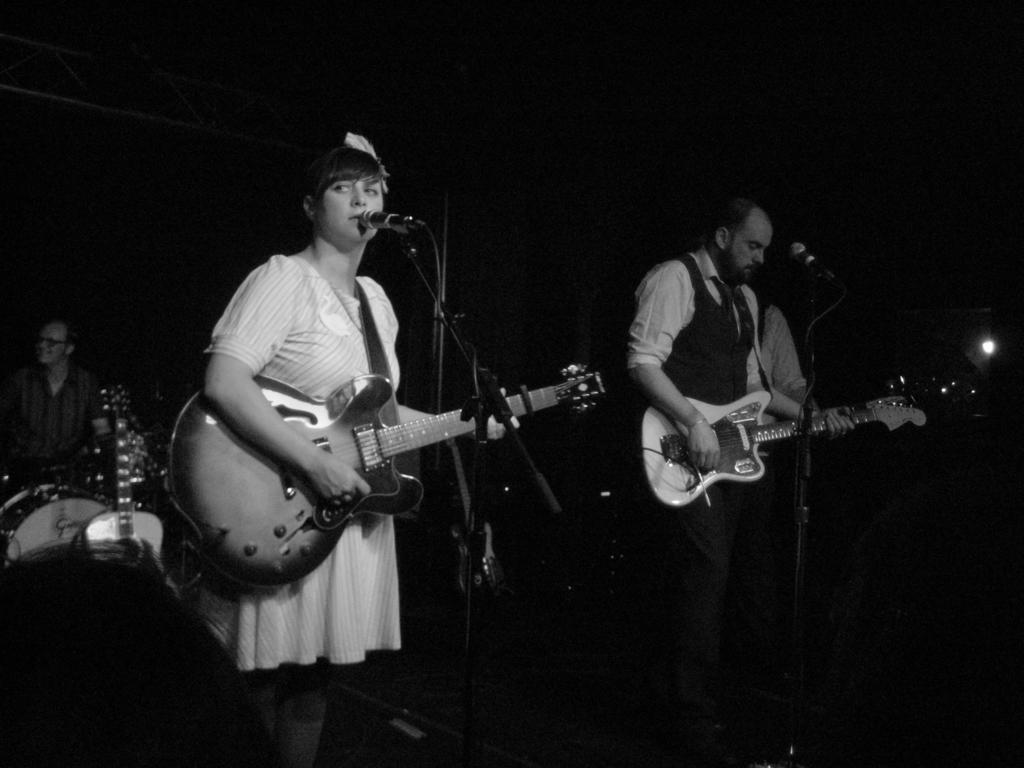Describe this image in one or two sentences. In the center of the image there are two people. The lady standing on the left is wearing a white dress, she is holding a guitar in her hand, next to her there is a man playing a guitar. There is a mic placed before him. In the background there is a man playing band. 